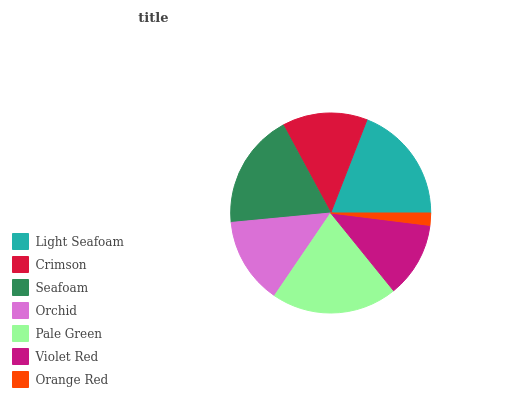Is Orange Red the minimum?
Answer yes or no. Yes. Is Pale Green the maximum?
Answer yes or no. Yes. Is Crimson the minimum?
Answer yes or no. No. Is Crimson the maximum?
Answer yes or no. No. Is Light Seafoam greater than Crimson?
Answer yes or no. Yes. Is Crimson less than Light Seafoam?
Answer yes or no. Yes. Is Crimson greater than Light Seafoam?
Answer yes or no. No. Is Light Seafoam less than Crimson?
Answer yes or no. No. Is Orchid the high median?
Answer yes or no. Yes. Is Orchid the low median?
Answer yes or no. Yes. Is Crimson the high median?
Answer yes or no. No. Is Crimson the low median?
Answer yes or no. No. 